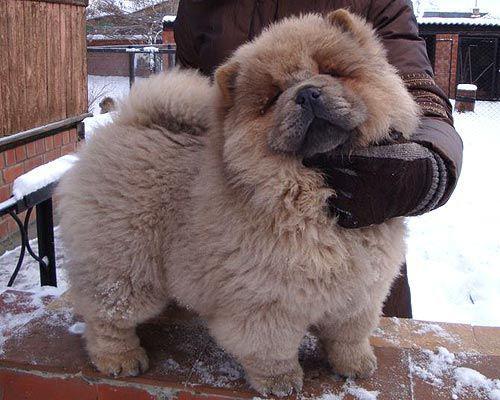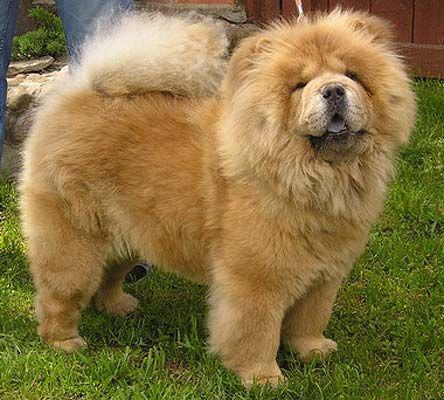The first image is the image on the left, the second image is the image on the right. Analyze the images presented: Is the assertion "There are two dogs standing on four legs." valid? Answer yes or no. Yes. The first image is the image on the left, the second image is the image on the right. Assess this claim about the two images: "One image features a person behind a chow posed standing on all fours and looking toward the camera.". Correct or not? Answer yes or no. Yes. 